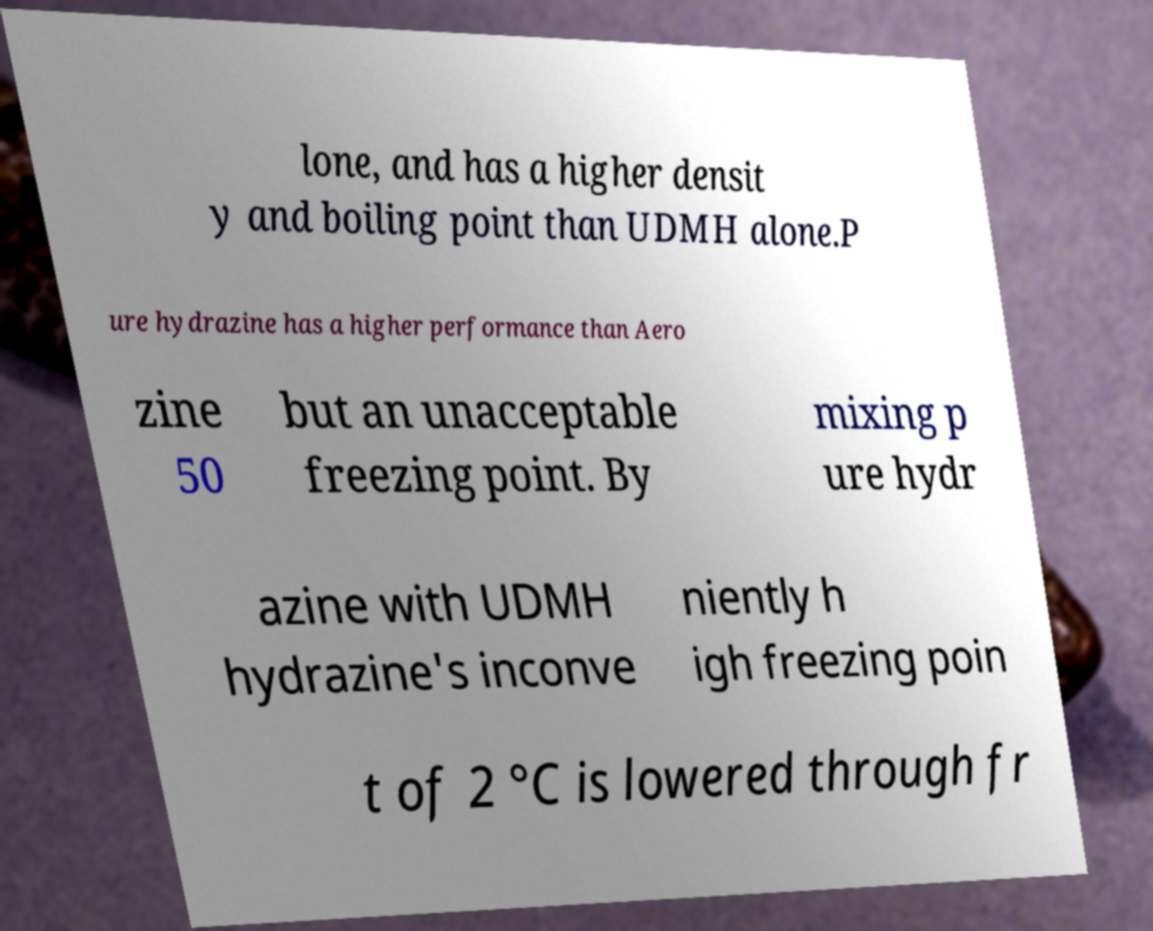Can you accurately transcribe the text from the provided image for me? lone, and has a higher densit y and boiling point than UDMH alone.P ure hydrazine has a higher performance than Aero zine 50 but an unacceptable freezing point. By mixing p ure hydr azine with UDMH hydrazine's inconve niently h igh freezing poin t of 2 °C is lowered through fr 